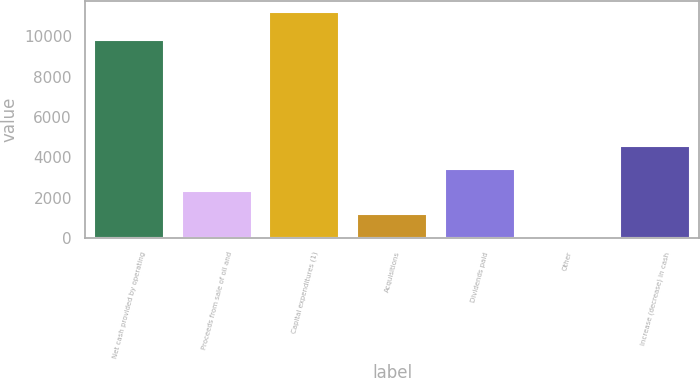<chart> <loc_0><loc_0><loc_500><loc_500><bar_chart><fcel>Net cash provided by operating<fcel>Proceeds from sale of oil and<fcel>Capital expenditures (1)<fcel>Acquisitions<fcel>Dividends paid<fcel>Other<fcel>Increase (decrease) in cash<nl><fcel>9835<fcel>2312.8<fcel>11220<fcel>1199.4<fcel>3426.2<fcel>86<fcel>4539.6<nl></chart> 